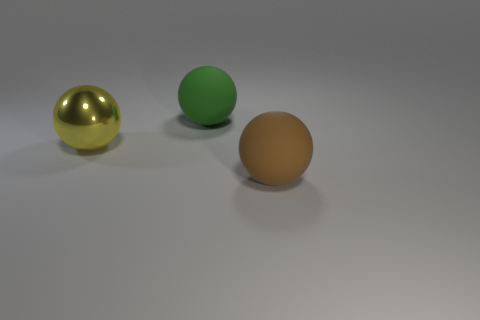Subtract all green balls. How many balls are left? 2 Add 1 large gray metal objects. How many objects exist? 4 Subtract 1 spheres. How many spheres are left? 2 Add 3 tiny purple metal cylinders. How many tiny purple metal cylinders exist? 3 Subtract 0 cyan blocks. How many objects are left? 3 Subtract all red spheres. Subtract all yellow cylinders. How many spheres are left? 3 Subtract all green rubber cylinders. Subtract all big rubber spheres. How many objects are left? 1 Add 2 metal balls. How many metal balls are left? 3 